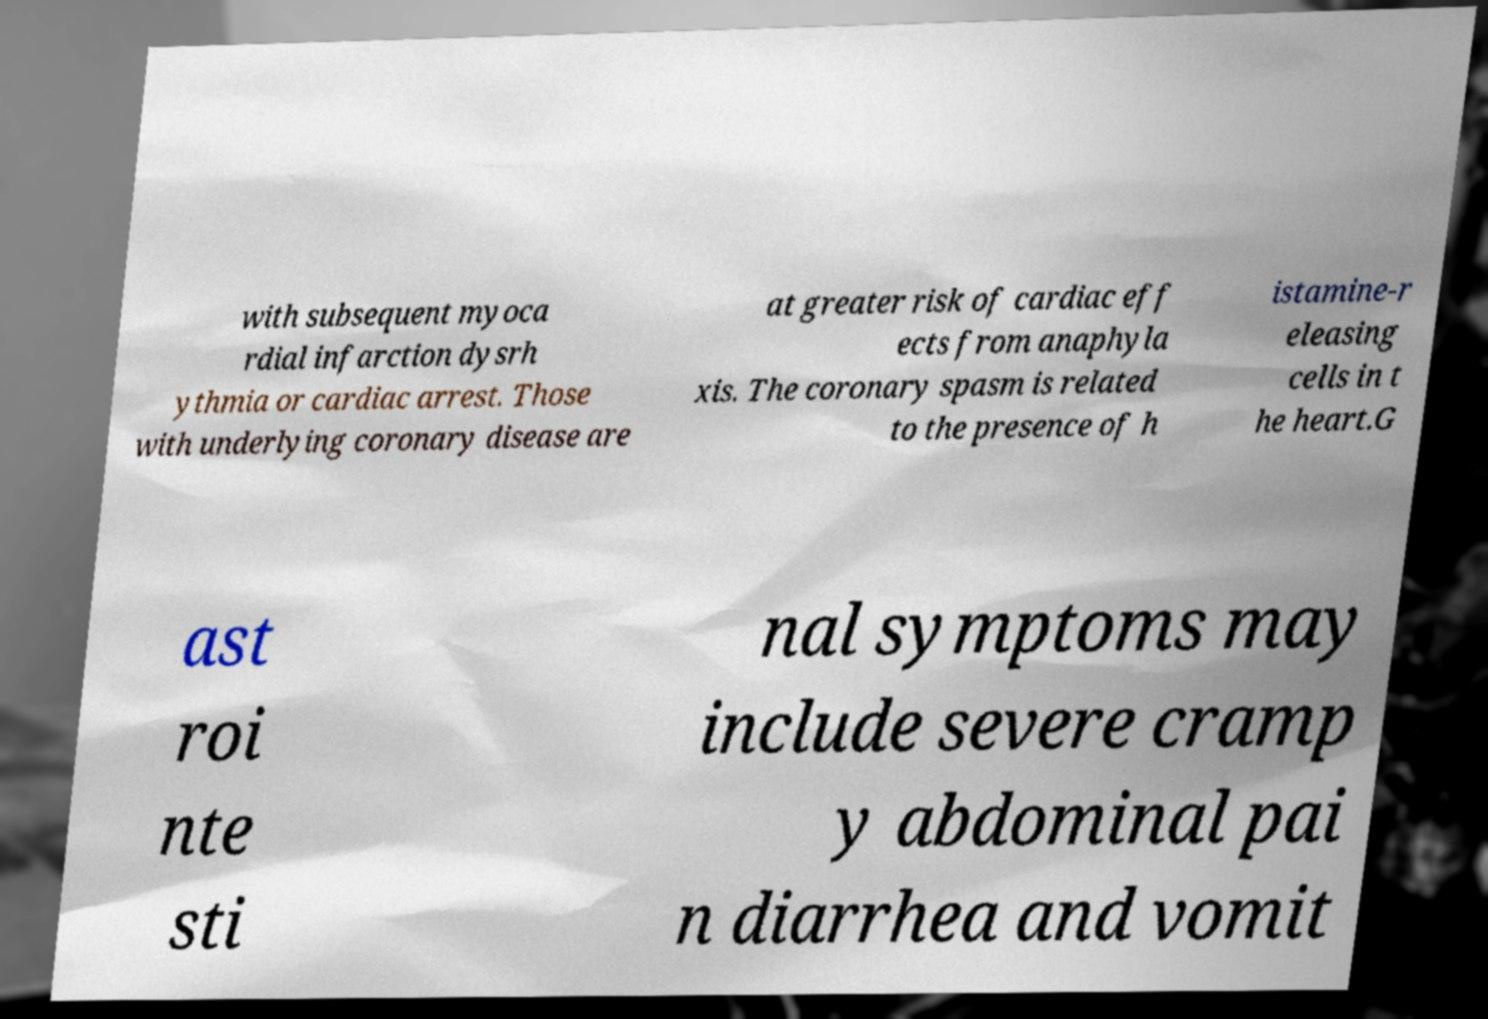I need the written content from this picture converted into text. Can you do that? with subsequent myoca rdial infarction dysrh ythmia or cardiac arrest. Those with underlying coronary disease are at greater risk of cardiac eff ects from anaphyla xis. The coronary spasm is related to the presence of h istamine-r eleasing cells in t he heart.G ast roi nte sti nal symptoms may include severe cramp y abdominal pai n diarrhea and vomit 